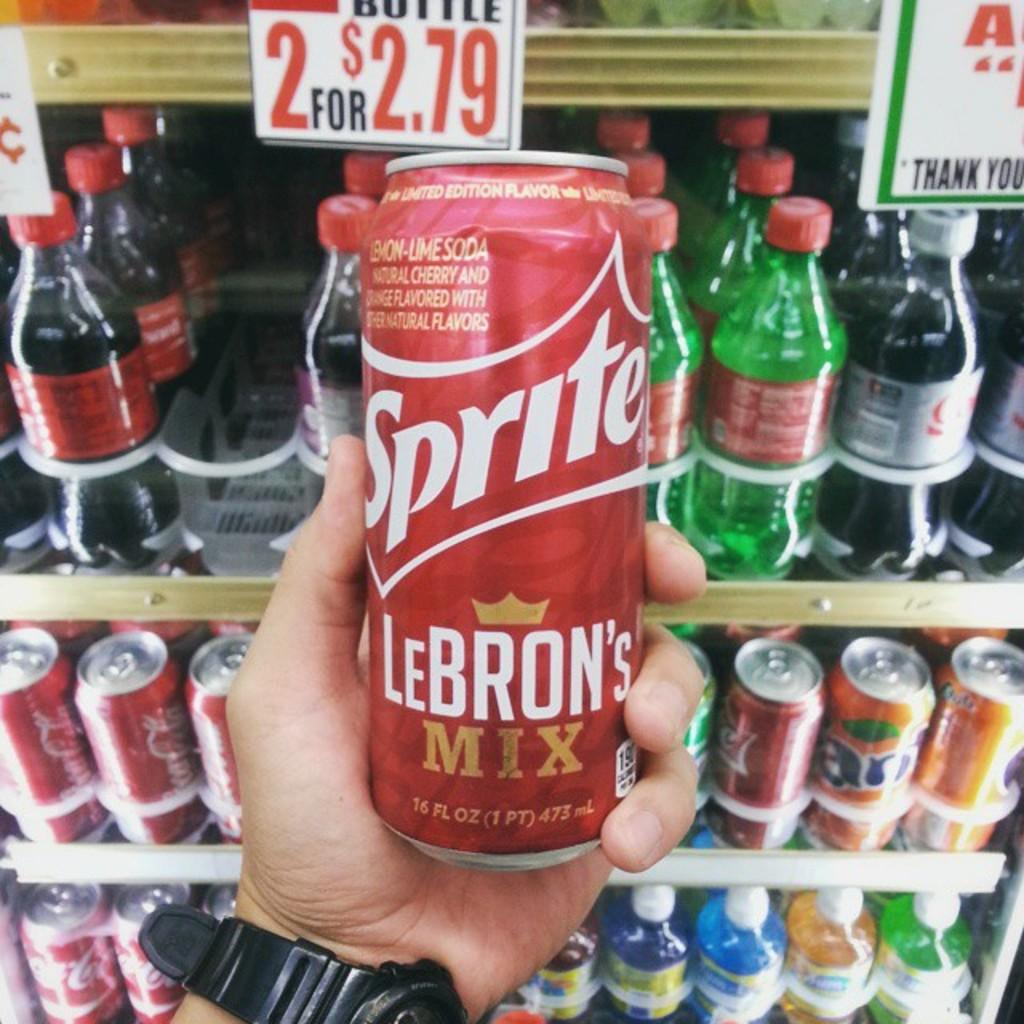<image>
Present a compact description of the photo's key features. A man is holding a can of red Sprite 